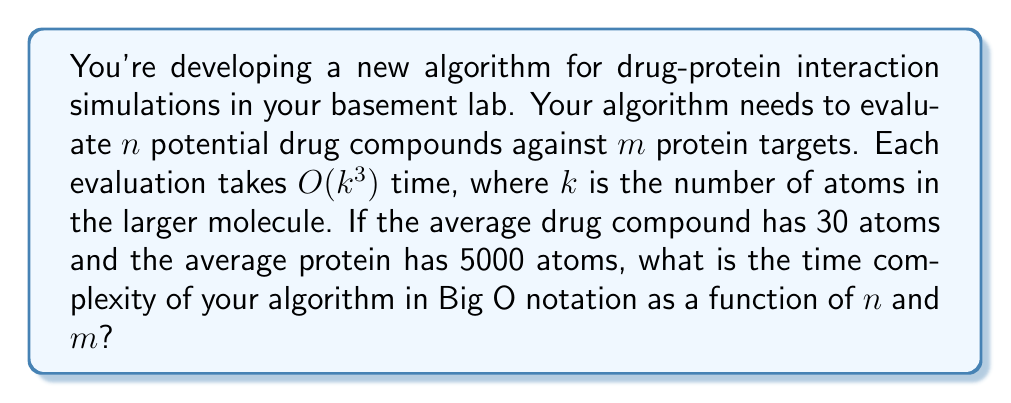Help me with this question. Let's break this down step-by-step:

1) First, we need to determine the value of $k$ for each evaluation. Since $k$ is the number of atoms in the larger molecule, and proteins (5000 atoms) are larger than drug compounds (30 atoms), $k = 5000$ for each evaluation.

2) Each individual evaluation takes $O(k^3)$ time. Substituting $k = 5000$:
   
   $O(5000^3) = O(1.25 \times 10^{11})$

3) This is a constant value (albeit a large one) in terms of $n$ and $m$. In Big O notation, we can simplify this to $O(1)$ for each individual evaluation.

4) Now, we need to consider how many evaluations are performed. We're evaluating $n$ drug compounds against $m$ protein targets. This means we're performing $n \times m$ evaluations in total.

5) Each of these $n \times m$ evaluations takes $O(1)$ time (in terms of $n$ and $m$).

6) Therefore, the total time complexity is:

   $O(n \times m \times 1) = O(nm)$

This represents the number of individual evaluations multiplied by the time complexity of each evaluation.
Answer: $O(nm)$ 